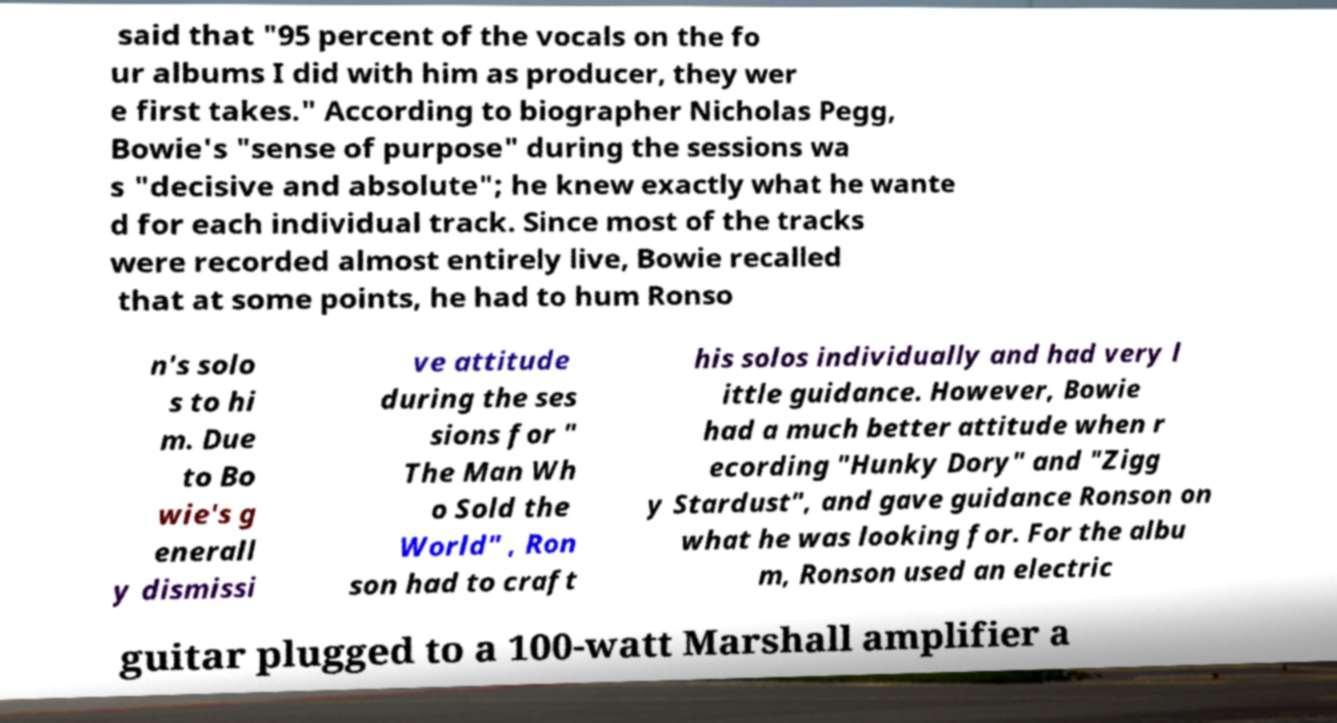Can you read and provide the text displayed in the image?This photo seems to have some interesting text. Can you extract and type it out for me? said that "95 percent of the vocals on the fo ur albums I did with him as producer, they wer e first takes." According to biographer Nicholas Pegg, Bowie's "sense of purpose" during the sessions wa s "decisive and absolute"; he knew exactly what he wante d for each individual track. Since most of the tracks were recorded almost entirely live, Bowie recalled that at some points, he had to hum Ronso n's solo s to hi m. Due to Bo wie's g enerall y dismissi ve attitude during the ses sions for " The Man Wh o Sold the World" , Ron son had to craft his solos individually and had very l ittle guidance. However, Bowie had a much better attitude when r ecording "Hunky Dory" and "Zigg y Stardust", and gave guidance Ronson on what he was looking for. For the albu m, Ronson used an electric guitar plugged to a 100-watt Marshall amplifier a 